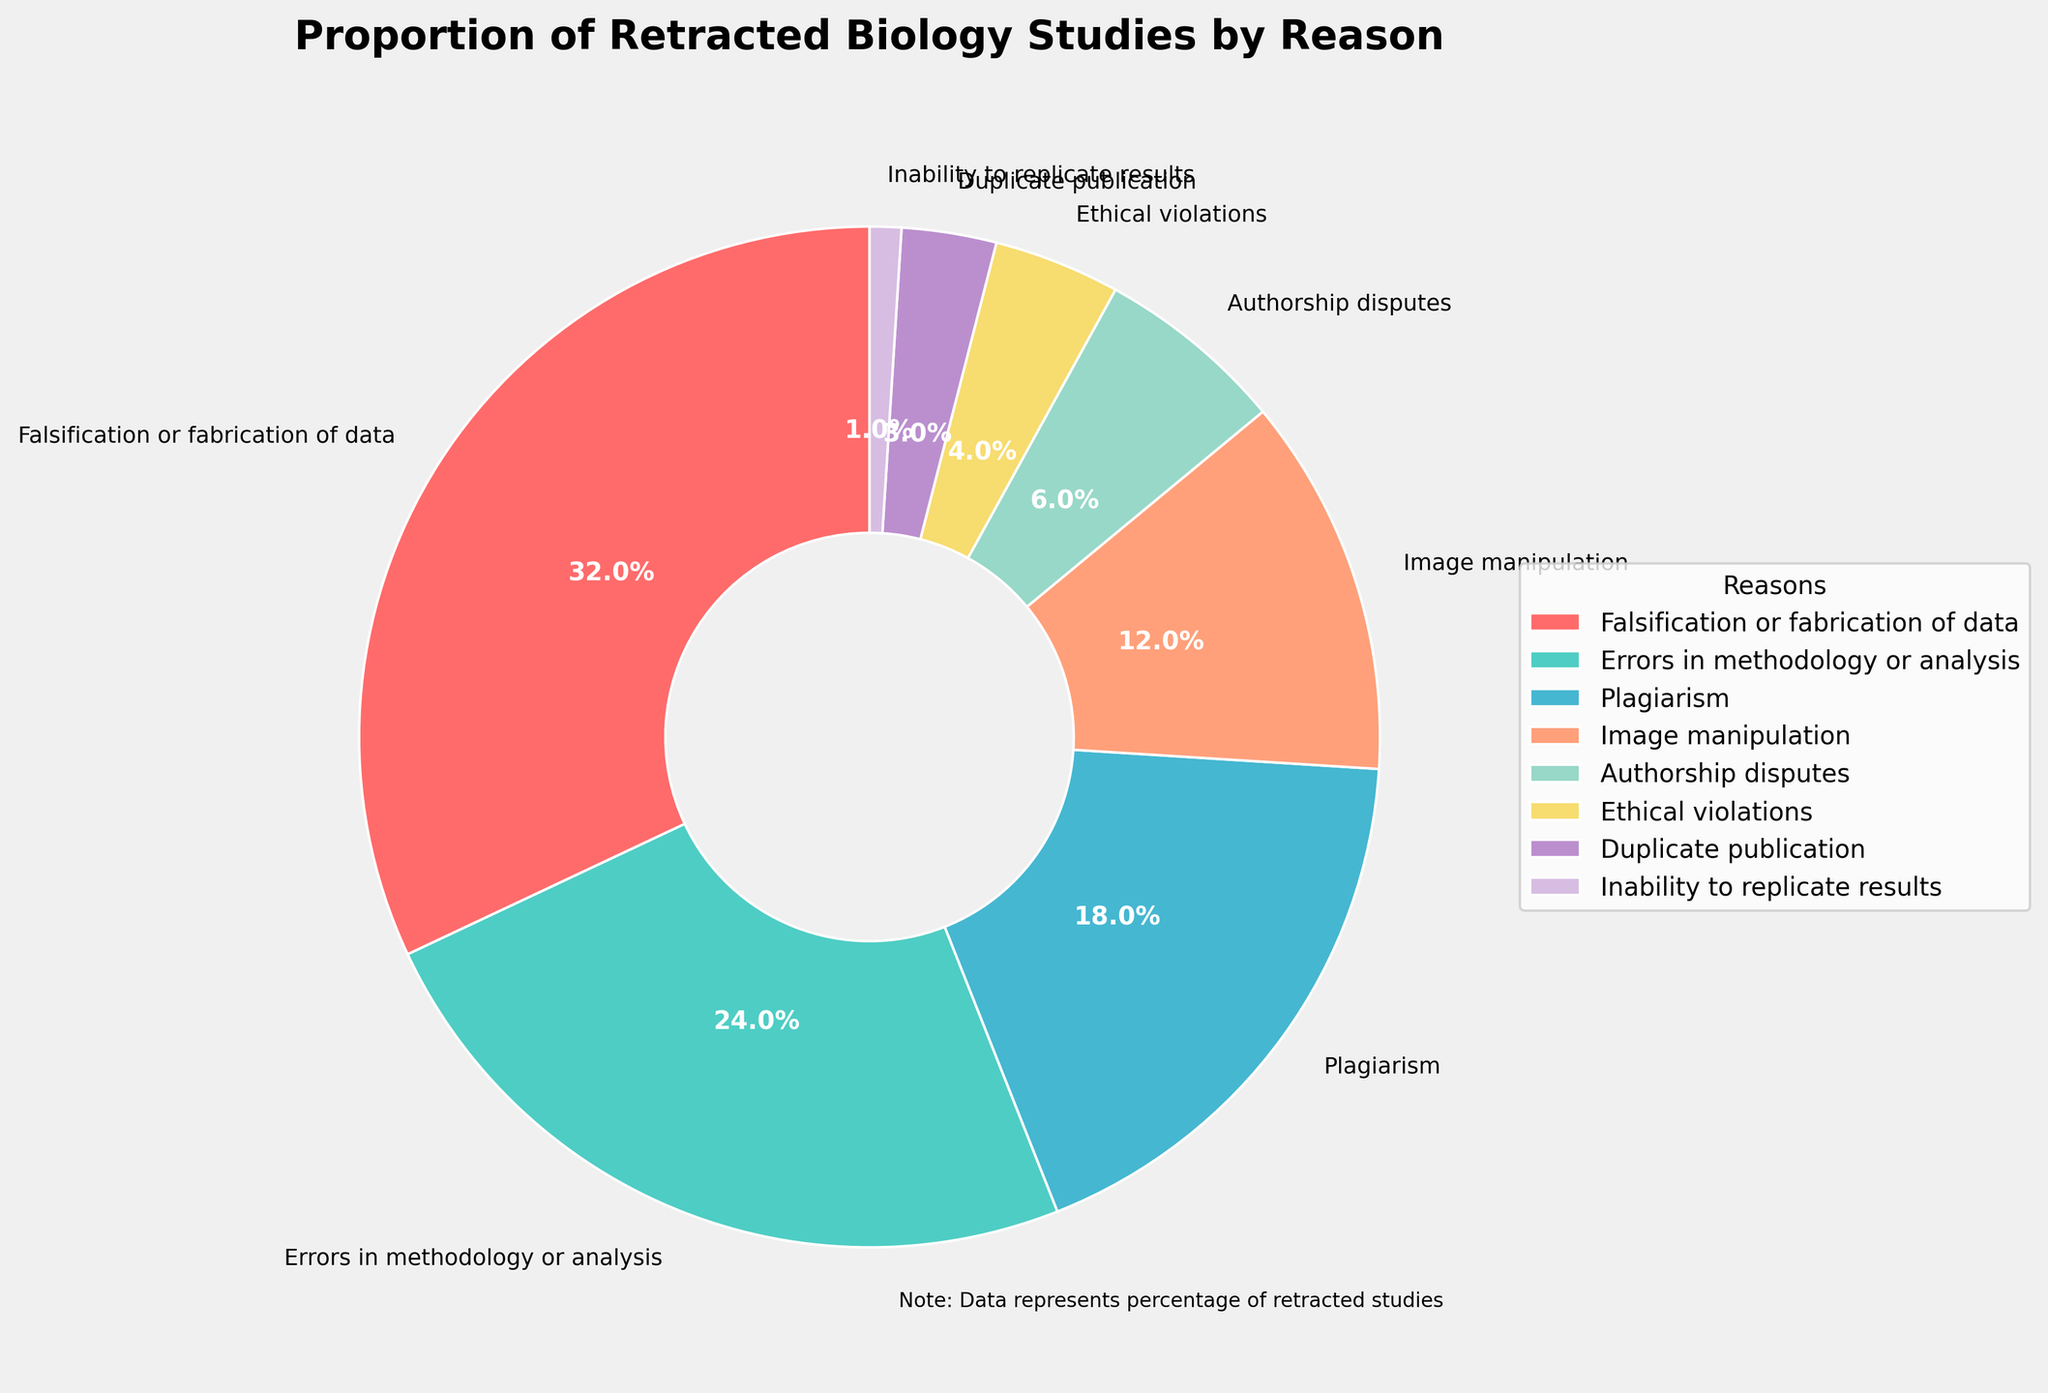Which reason accounts for the largest proportion of retracted studies? The wedge with the largest proportion represents 'Falsification or fabrication of data' at 32%.
Answer: Falsification or fabrication of data What is the combined percentage of studies retracted due to errors in methodology or analysis and plagiarism? Adding the percentages of 'Errors in methodology or analysis' (24%) and 'Plagiarism' (18%) gives a combined total of 24 + 18 = 42%.
Answer: 42% Which reasons make up less than 5% of retracted studies? The wedges representing 'Ethical violations' (4%), 'Duplicate publication' (3%), and 'Inability to replicate results' (1%) each make up less than 5% of the retracted studies.
Answer: Ethical violations, Duplicate publication, Inability to replicate results Is the proportion of studies retracted due to authorship disputes greater than those retracted due to duplicate publication? The wedge for 'Authorship disputes' (6%) is greater than the wedge for 'Duplicate publication' (3%).
Answer: Yes What is the second largest reason for retraction? The second largest wedge represents 'Errors in methodology or analysis' at 24%.
Answer: Errors in methodology or analysis How much more significant is fraud-related retraction compared to image manipulation? The proportion for 'Falsification or fabrication of data' (32%) minus that of 'Image manipulation' (12%) equals 32 - 12 = 20%.
Answer: 20% Which color wedge represents image manipulation? The wedge labeled 'Image manipulation' is in light orange.
Answer: Light orange Between plagiarism and image manipulation, which has a smaller proportion of retracted studies? The wedge for 'Image manipulation' (12%) is smaller than the wedge for 'Plagiarism' (18%).
Answer: Image manipulation If we combine the percentages of authorship disputes and duplicate publication, do they exceed those of image manipulation? Adding 'Authorship disputes' (6%) and 'Duplicate publication' (3%) gives 6 + 3 = 9%, which is less than the 12% for 'Image manipulation'.
Answer: No What percentage of studies are retracted due to ethical violations or inability to replicate results? Adding 'Ethical violations' (4%) and 'Inability to replicate results' (1%) gives a total of 4 + 1 = 5%.
Answer: 5% 